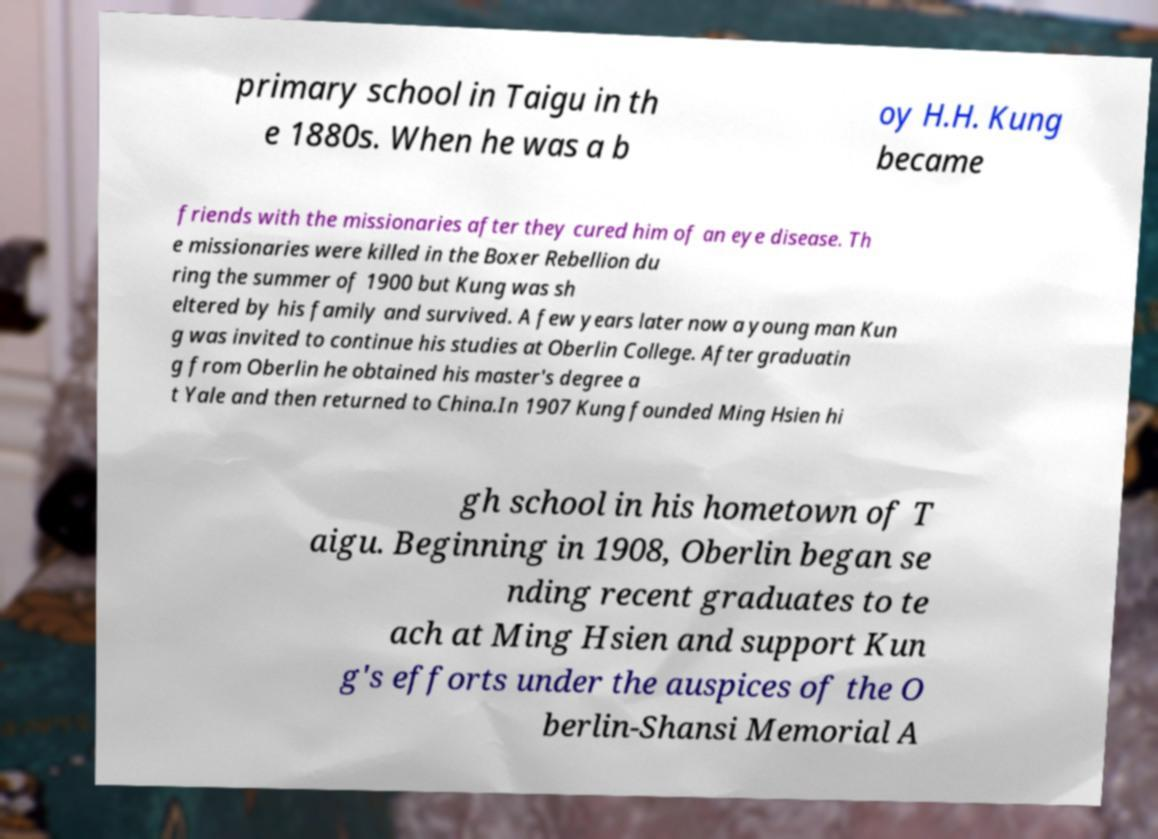What messages or text are displayed in this image? I need them in a readable, typed format. primary school in Taigu in th e 1880s. When he was a b oy H.H. Kung became friends with the missionaries after they cured him of an eye disease. Th e missionaries were killed in the Boxer Rebellion du ring the summer of 1900 but Kung was sh eltered by his family and survived. A few years later now a young man Kun g was invited to continue his studies at Oberlin College. After graduatin g from Oberlin he obtained his master's degree a t Yale and then returned to China.In 1907 Kung founded Ming Hsien hi gh school in his hometown of T aigu. Beginning in 1908, Oberlin began se nding recent graduates to te ach at Ming Hsien and support Kun g's efforts under the auspices of the O berlin-Shansi Memorial A 